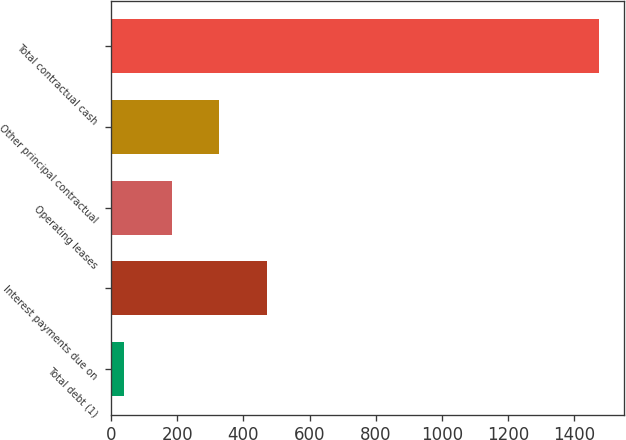Convert chart. <chart><loc_0><loc_0><loc_500><loc_500><bar_chart><fcel>Total debt (1)<fcel>Interest payments due on<fcel>Operating leases<fcel>Other principal contractual<fcel>Total contractual cash<nl><fcel>41<fcel>471.41<fcel>184.47<fcel>327.94<fcel>1475.7<nl></chart> 